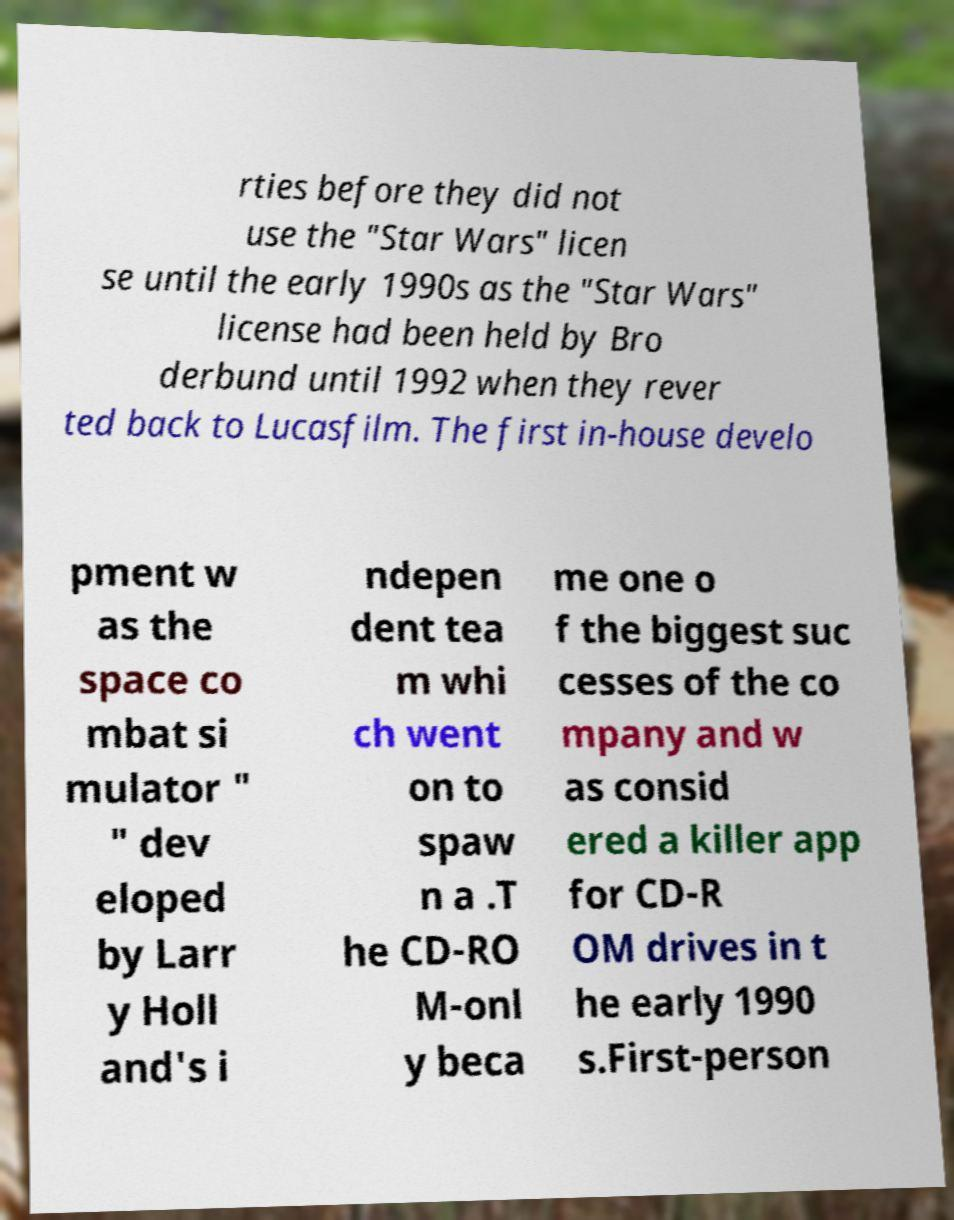There's text embedded in this image that I need extracted. Can you transcribe it verbatim? rties before they did not use the "Star Wars" licen se until the early 1990s as the "Star Wars" license had been held by Bro derbund until 1992 when they rever ted back to Lucasfilm. The first in-house develo pment w as the space co mbat si mulator " " dev eloped by Larr y Holl and's i ndepen dent tea m whi ch went on to spaw n a .T he CD-RO M-onl y beca me one o f the biggest suc cesses of the co mpany and w as consid ered a killer app for CD-R OM drives in t he early 1990 s.First-person 